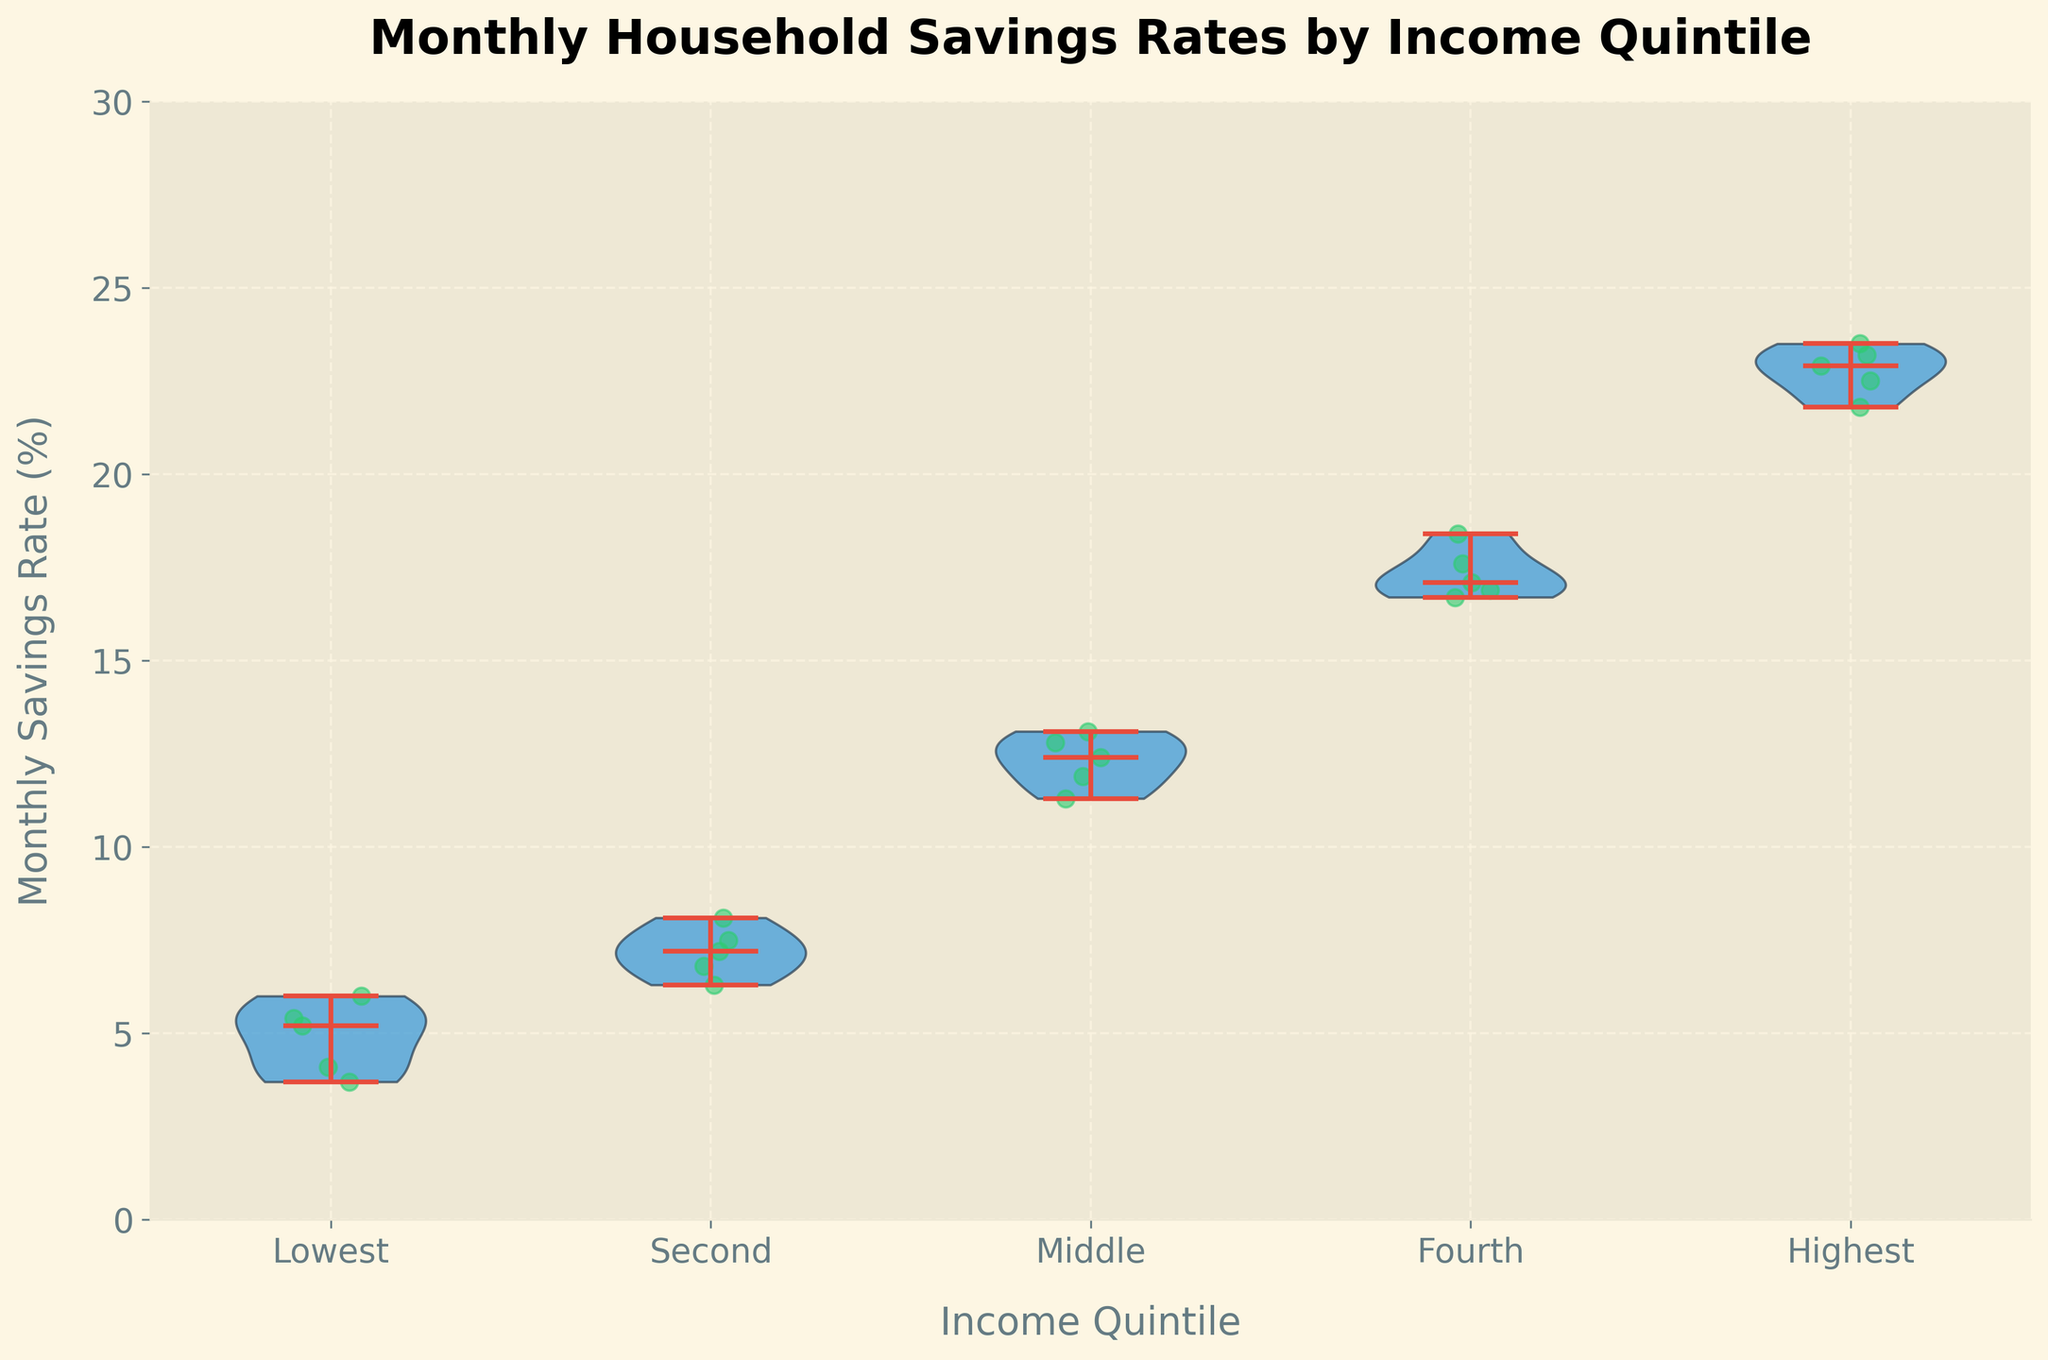what is the title of the plot? The title is displayed at the top of the figure. In this case, it reads "Monthly Household Savings Rates by Income Quintile."
Answer: Monthly Household Savings Rates by Income Quintile Which income quintile has the highest median monthly savings rate? By examining the violin plot, the horizontal line within the violin plot representing the median, the highest median line is in the "Highest" income quintile.
Answer: Highest What is the range of the monthly savings rate for the middle-income quintile? The range is found by identifying the lowest and highest points of the distribution for the middle-income quintile. From the figure, the lowest savings rate is approximately 11.3% and the highest is about 13.1%.
Answer: 11.3% to 13.1% How does the median savings rate of the lowest quintile compare to the second quintile? Look at the median lines in the violins for both quintiles. The median line for the lowest quintile is lower than for the second quintile.
Answer: The median for the lowest quintile is lower than the second quintile What is the approximate interquartile range (IQR) of the highest income quintile savings rate? The IQR is found by subtracting the 25th percentile from the 75th percentile in the violin plot. In the Highest income quintile, the 75th percentile is around 23.2% and the 25th percentile is around 21.8%, so IQR = 23.2% - 21.8%.
Answer: 1.4% Are there any outliers in the savings rates for any quintile? Outliers are usually shown as individual points outside the main body of the violin plot. In this figure, points are scattered but do not appear as distinct outliers well away from the violins.
Answer: No What is the approximate width of the distribution for the Fourth income quintile? The width of the violin plot gives a visual indication of the density of data points. The Fourth quintile plot is moderately wide, reflecting moderate variance with savings rates roughly between 16.7% and 18.4%.
Answer: 1.7% Which quintile shows the greatest variance in monthly savings rates? The variance can be judged by the width and extent of the violin plots. The Fourth quintile has the widest and most varied distribution, indicating the greatest variance.
Answer: Fourth What color is used to indicate the individual data points? Each individual savings rate data point is shown with the color green within the scatter plot overlaid on the violins.
Answer: Green What can be inferred about the general trend in savings rates across the income quintiles? Observing the medians and spread of the violin plots, a clear upward trend in savings rates can be seen. Higher income quintiles tend to have higher median savings rates and generally higher overall savings rates.
Answer: Higher income quintiles have higher savings rates 